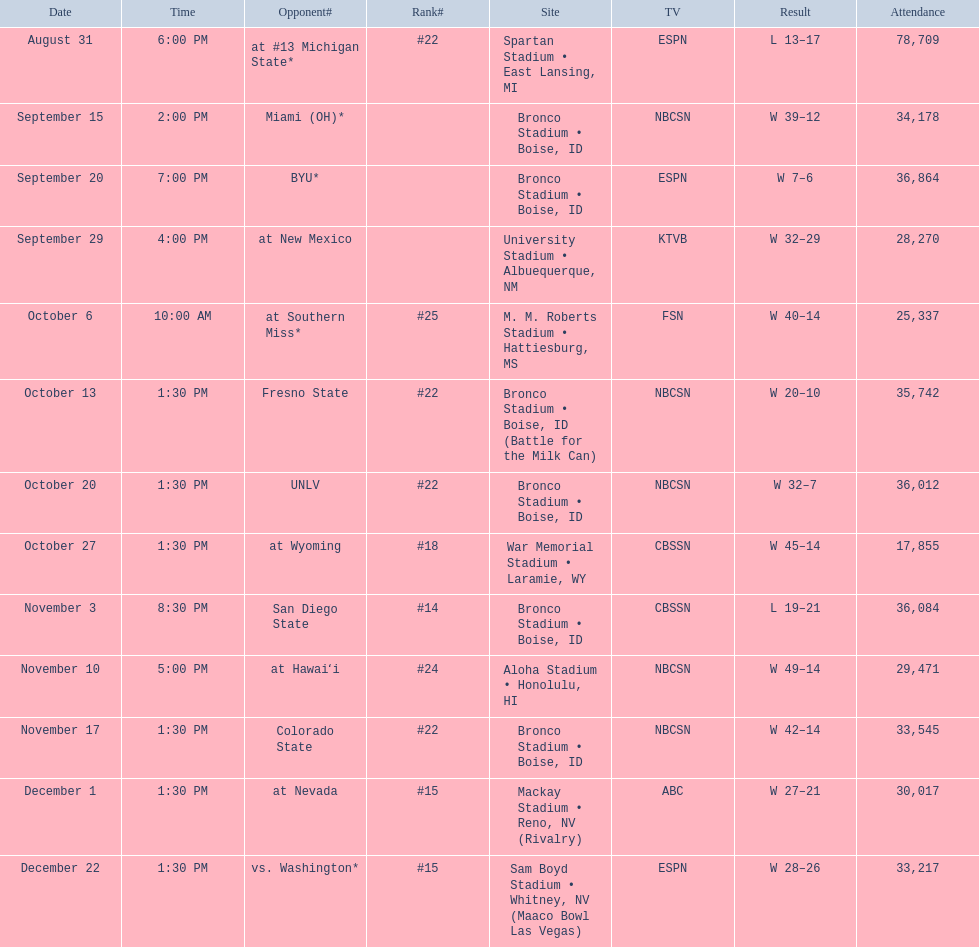Write the full table. {'header': ['Date', 'Time', 'Opponent#', 'Rank#', 'Site', 'TV', 'Result', 'Attendance'], 'rows': [['August 31', '6:00 PM', 'at\xa0#13\xa0Michigan State*', '#22', 'Spartan Stadium • East Lansing, MI', 'ESPN', 'L\xa013–17', '78,709'], ['September 15', '2:00 PM', 'Miami (OH)*', '', 'Bronco Stadium • Boise, ID', 'NBCSN', 'W\xa039–12', '34,178'], ['September 20', '7:00 PM', 'BYU*', '', 'Bronco Stadium • Boise, ID', 'ESPN', 'W\xa07–6', '36,864'], ['September 29', '4:00 PM', 'at\xa0New Mexico', '', 'University Stadium • Albuequerque, NM', 'KTVB', 'W\xa032–29', '28,270'], ['October 6', '10:00 AM', 'at\xa0Southern Miss*', '#25', 'M. M. Roberts Stadium • Hattiesburg, MS', 'FSN', 'W\xa040–14', '25,337'], ['October 13', '1:30 PM', 'Fresno State', '#22', 'Bronco Stadium • Boise, ID (Battle for the Milk Can)', 'NBCSN', 'W\xa020–10', '35,742'], ['October 20', '1:30 PM', 'UNLV', '#22', 'Bronco Stadium • Boise, ID', 'NBCSN', 'W\xa032–7', '36,012'], ['October 27', '1:30 PM', 'at\xa0Wyoming', '#18', 'War Memorial Stadium • Laramie, WY', 'CBSSN', 'W\xa045–14', '17,855'], ['November 3', '8:30 PM', 'San Diego State', '#14', 'Bronco Stadium • Boise, ID', 'CBSSN', 'L\xa019–21', '36,084'], ['November 10', '5:00 PM', 'at\xa0Hawaiʻi', '#24', 'Aloha Stadium • Honolulu, HI', 'NBCSN', 'W\xa049–14', '29,471'], ['November 17', '1:30 PM', 'Colorado State', '#22', 'Bronco Stadium • Boise, ID', 'NBCSN', 'W\xa042–14', '33,545'], ['December 1', '1:30 PM', 'at\xa0Nevada', '#15', 'Mackay Stadium • Reno, NV (Rivalry)', 'ABC', 'W\xa027–21', '30,017'], ['December 22', '1:30 PM', 'vs.\xa0Washington*', '#15', 'Sam Boyd Stadium • Whitney, NV (Maaco Bowl Las Vegas)', 'ESPN', 'W\xa028–26', '33,217']]} Number of points scored by miami (oh) against the broncos. 12. 